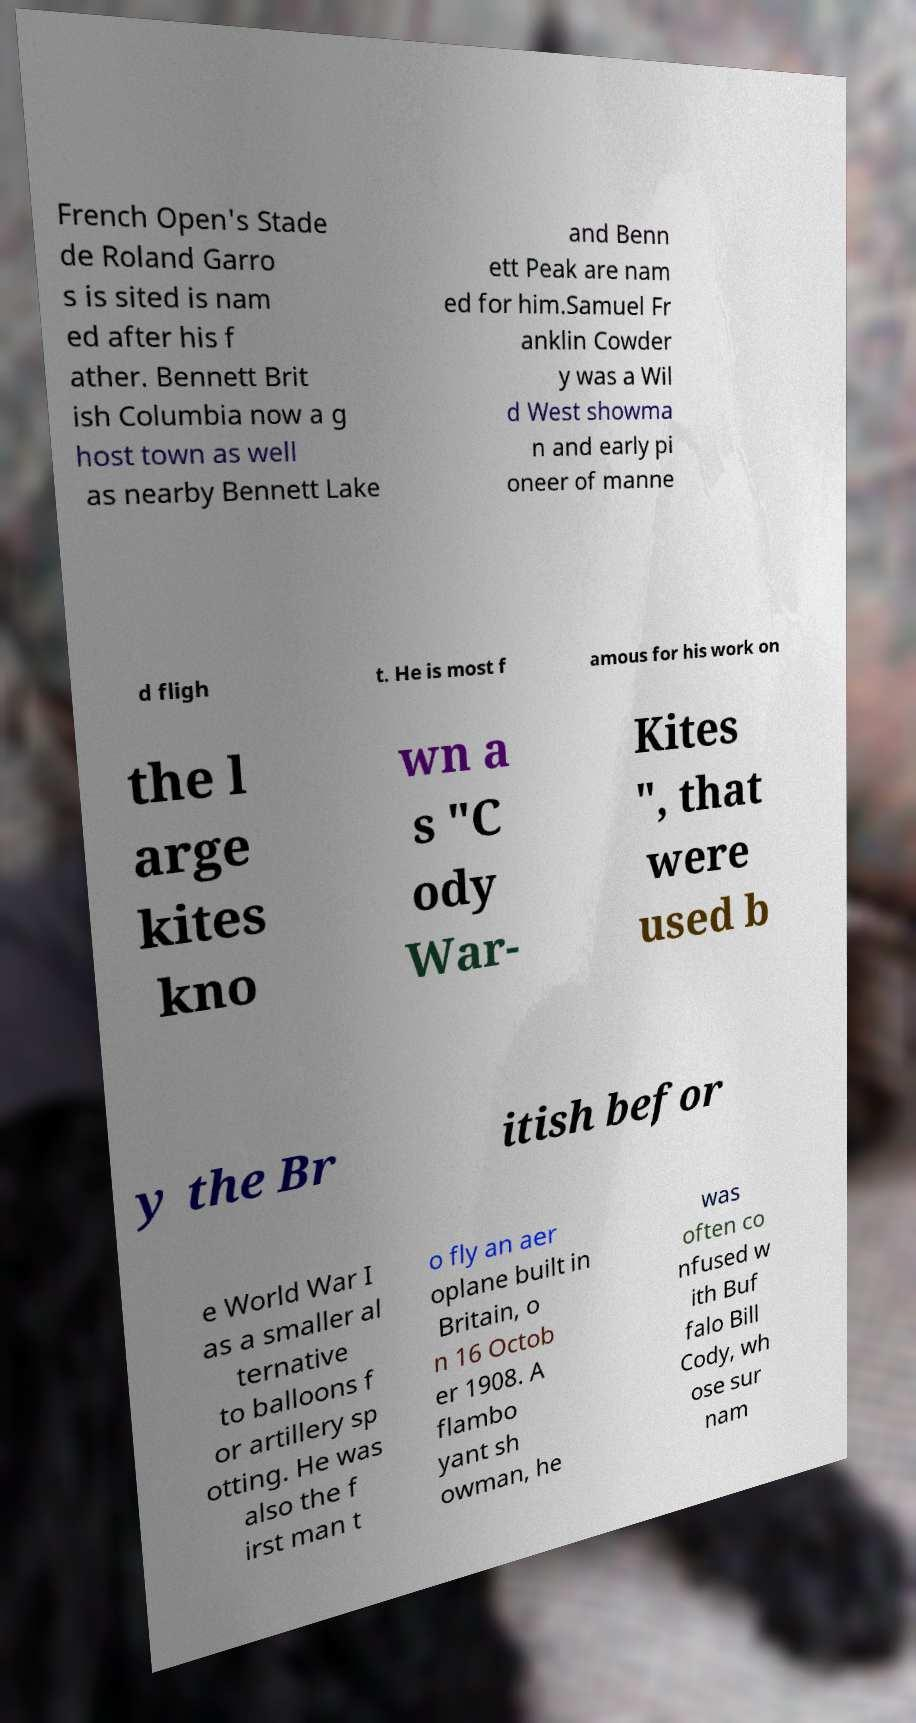Could you extract and type out the text from this image? French Open's Stade de Roland Garro s is sited is nam ed after his f ather. Bennett Brit ish Columbia now a g host town as well as nearby Bennett Lake and Benn ett Peak are nam ed for him.Samuel Fr anklin Cowder y was a Wil d West showma n and early pi oneer of manne d fligh t. He is most f amous for his work on the l arge kites kno wn a s "C ody War- Kites ", that were used b y the Br itish befor e World War I as a smaller al ternative to balloons f or artillery sp otting. He was also the f irst man t o fly an aer oplane built in Britain, o n 16 Octob er 1908. A flambo yant sh owman, he was often co nfused w ith Buf falo Bill Cody, wh ose sur nam 